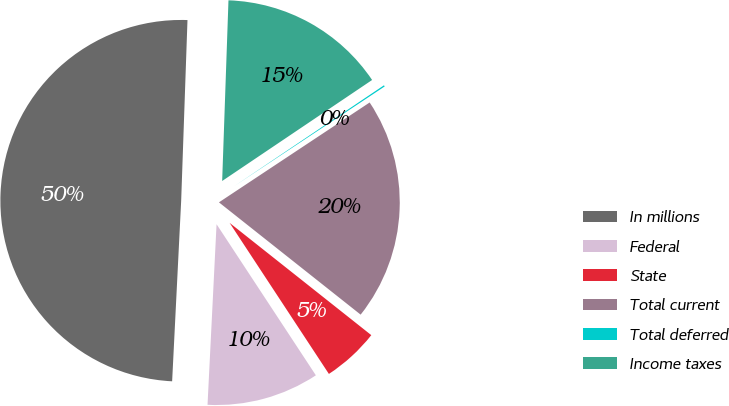<chart> <loc_0><loc_0><loc_500><loc_500><pie_chart><fcel>In millions<fcel>Federal<fcel>State<fcel>Total current<fcel>Total deferred<fcel>Income taxes<nl><fcel>49.76%<fcel>10.05%<fcel>5.08%<fcel>19.98%<fcel>0.12%<fcel>15.01%<nl></chart> 